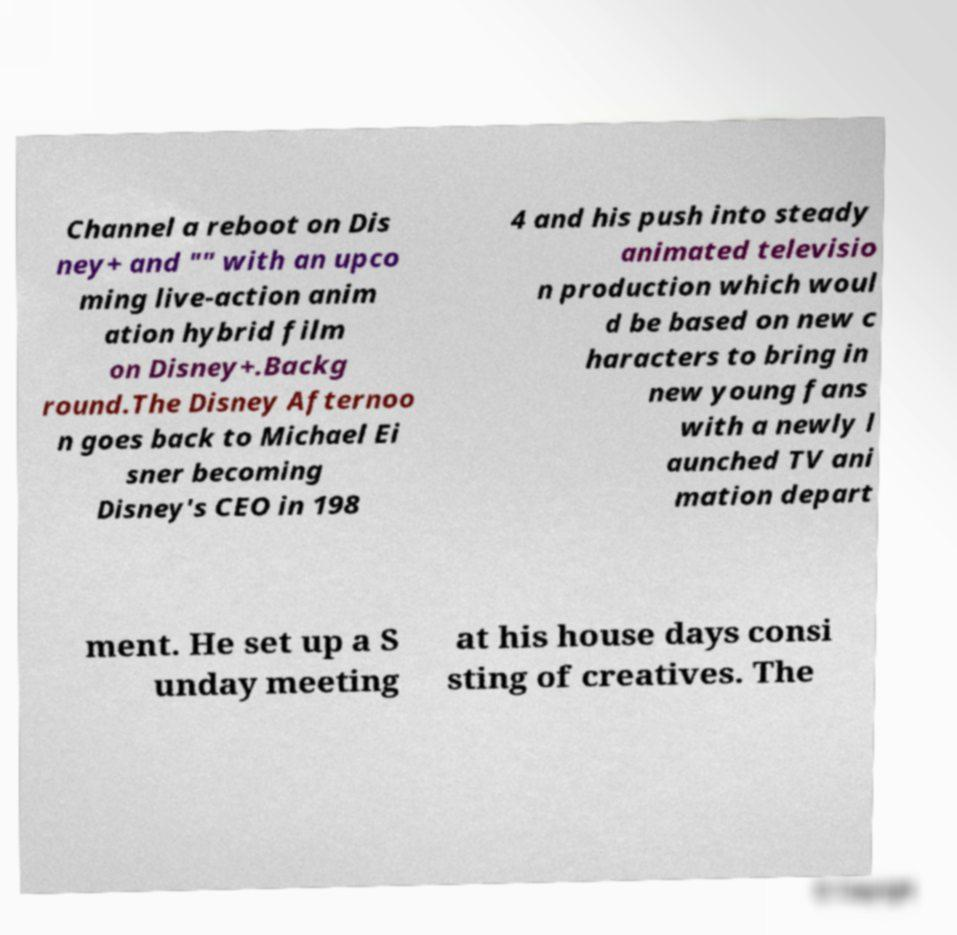I need the written content from this picture converted into text. Can you do that? Channel a reboot on Dis ney+ and "" with an upco ming live-action anim ation hybrid film on Disney+.Backg round.The Disney Afternoo n goes back to Michael Ei sner becoming Disney's CEO in 198 4 and his push into steady animated televisio n production which woul d be based on new c haracters to bring in new young fans with a newly l aunched TV ani mation depart ment. He set up a S unday meeting at his house days consi sting of creatives. The 